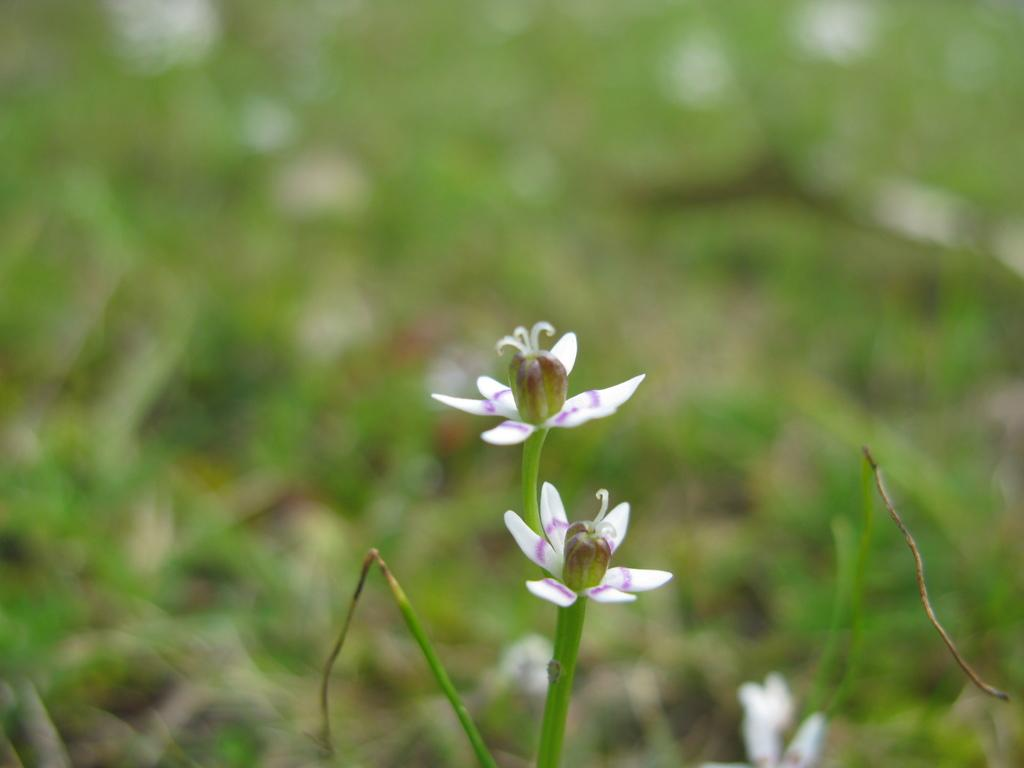What can be seen in the foreground of the picture? There are flowers and stems in the foreground of the picture. How would you describe the background of the image? The background of the image is blurred. What type of vegetation is visible in the background of the image? There is greenery in the background of the image. Are there any boats visible in the image? There are no boats present in the image. What type of news can be read on the flowers in the image? There is no news present in the image, as it features flowers and stems in the foreground. 